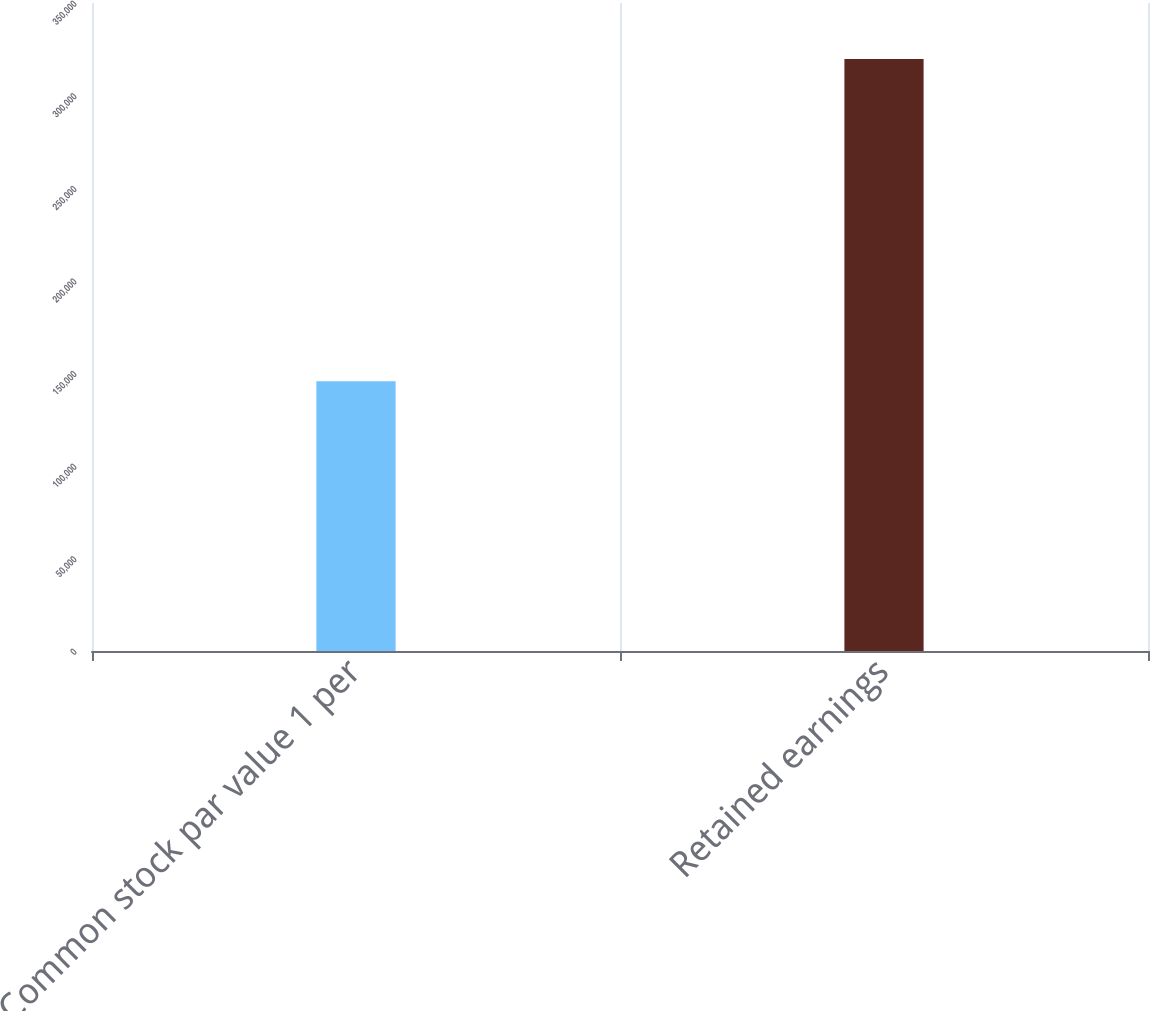Convert chart to OTSL. <chart><loc_0><loc_0><loc_500><loc_500><bar_chart><fcel>Common stock par value 1 per<fcel>Retained earnings<nl><fcel>145722<fcel>319803<nl></chart> 